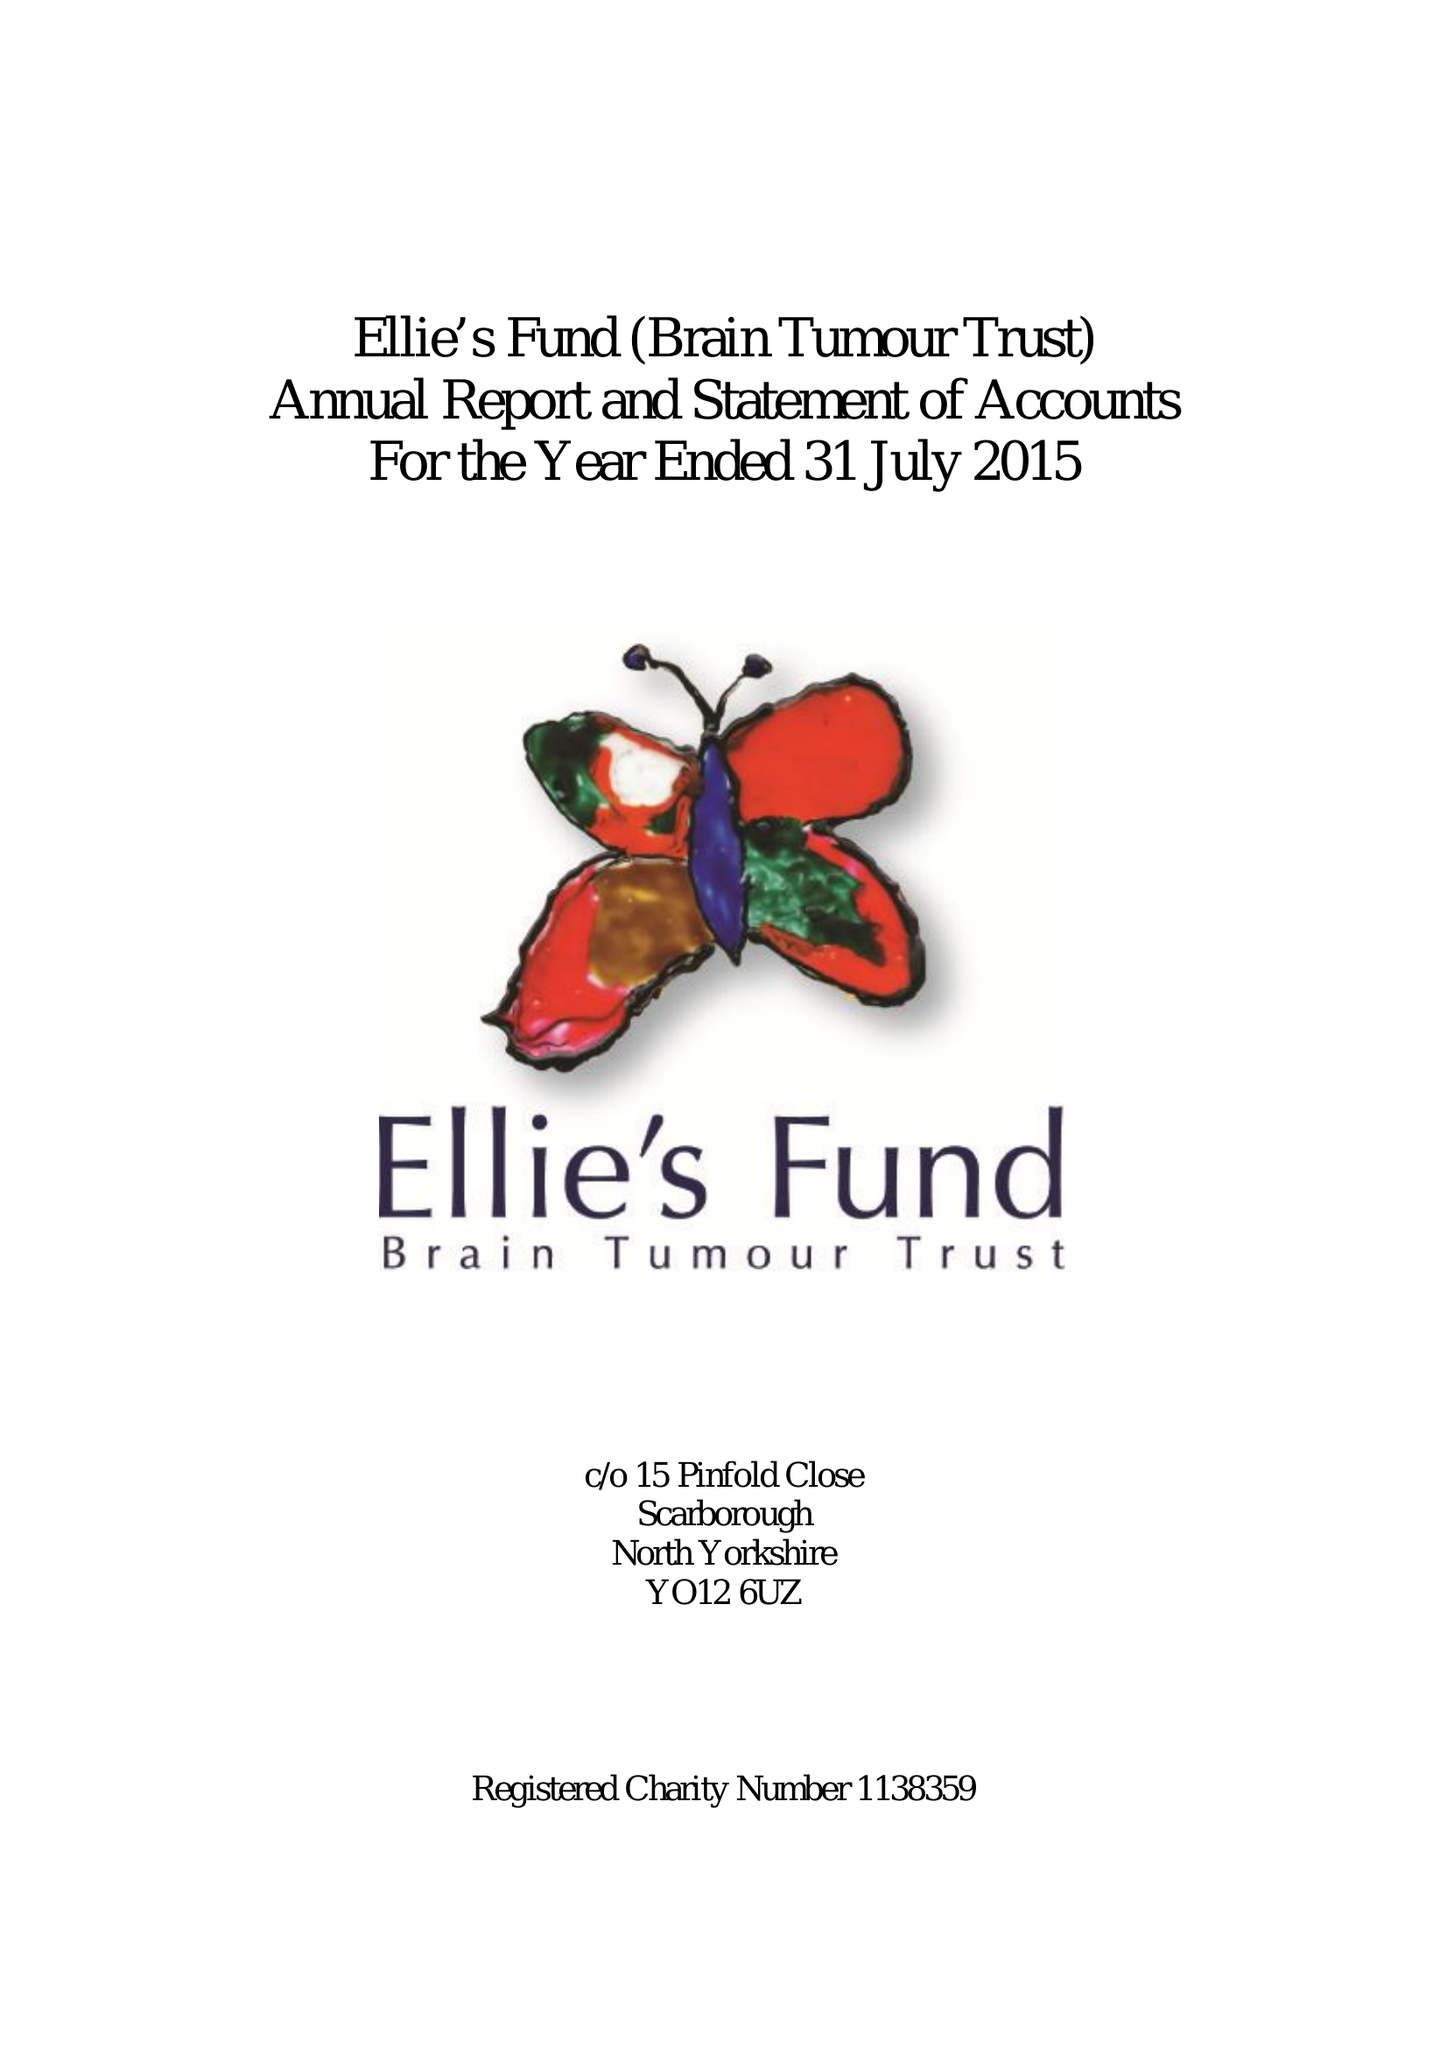What is the value for the income_annually_in_british_pounds?
Answer the question using a single word or phrase. 42533.00 